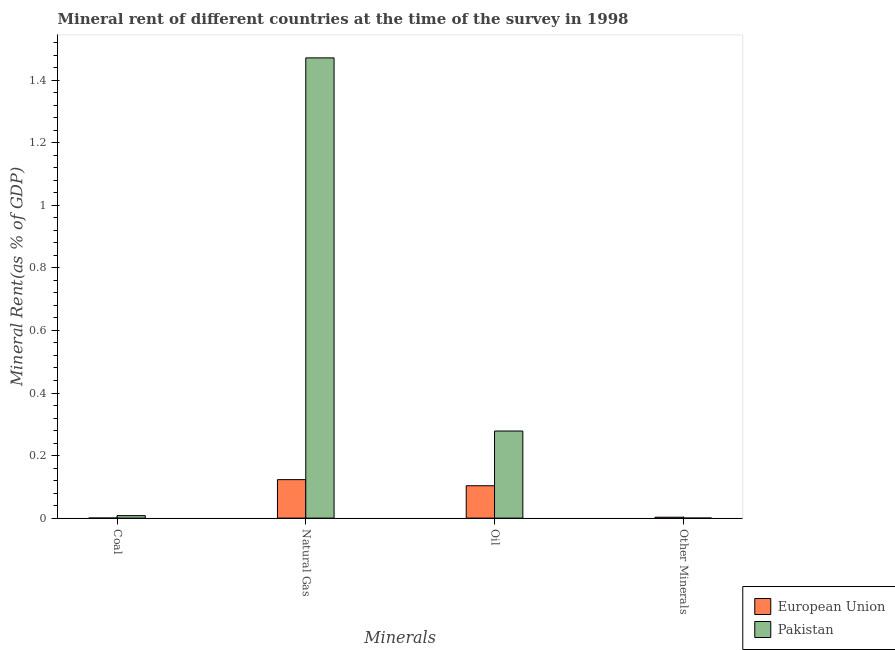How many groups of bars are there?
Give a very brief answer. 4. Are the number of bars per tick equal to the number of legend labels?
Your response must be concise. Yes. Are the number of bars on each tick of the X-axis equal?
Your answer should be very brief. Yes. How many bars are there on the 1st tick from the right?
Your response must be concise. 2. What is the label of the 2nd group of bars from the left?
Offer a terse response. Natural Gas. What is the natural gas rent in European Union?
Your response must be concise. 0.12. Across all countries, what is the maximum coal rent?
Provide a succinct answer. 0.01. Across all countries, what is the minimum  rent of other minerals?
Your response must be concise. 0. In which country was the coal rent maximum?
Your answer should be very brief. Pakistan. In which country was the  rent of other minerals minimum?
Provide a succinct answer. Pakistan. What is the total natural gas rent in the graph?
Make the answer very short. 1.59. What is the difference between the coal rent in European Union and that in Pakistan?
Provide a succinct answer. -0.01. What is the difference between the natural gas rent in European Union and the coal rent in Pakistan?
Ensure brevity in your answer.  0.11. What is the average  rent of other minerals per country?
Make the answer very short. 0. What is the difference between the  rent of other minerals and oil rent in Pakistan?
Your response must be concise. -0.28. In how many countries, is the coal rent greater than 0.28 %?
Provide a succinct answer. 0. What is the ratio of the  rent of other minerals in European Union to that in Pakistan?
Give a very brief answer. 25.04. Is the natural gas rent in European Union less than that in Pakistan?
Your answer should be very brief. Yes. Is the difference between the coal rent in European Union and Pakistan greater than the difference between the natural gas rent in European Union and Pakistan?
Give a very brief answer. Yes. What is the difference between the highest and the second highest  rent of other minerals?
Keep it short and to the point. 0. What is the difference between the highest and the lowest natural gas rent?
Ensure brevity in your answer.  1.35. Is the sum of the coal rent in Pakistan and European Union greater than the maximum  rent of other minerals across all countries?
Your answer should be very brief. Yes. Is it the case that in every country, the sum of the natural gas rent and  rent of other minerals is greater than the sum of oil rent and coal rent?
Provide a short and direct response. No. What does the 2nd bar from the right in Other Minerals represents?
Your answer should be compact. European Union. What is the difference between two consecutive major ticks on the Y-axis?
Your response must be concise. 0.2. Does the graph contain any zero values?
Keep it short and to the point. No. Where does the legend appear in the graph?
Keep it short and to the point. Bottom right. How are the legend labels stacked?
Your answer should be compact. Vertical. What is the title of the graph?
Provide a short and direct response. Mineral rent of different countries at the time of the survey in 1998. What is the label or title of the X-axis?
Your answer should be very brief. Minerals. What is the label or title of the Y-axis?
Ensure brevity in your answer.  Mineral Rent(as % of GDP). What is the Mineral Rent(as % of GDP) of European Union in Coal?
Your answer should be very brief. 0. What is the Mineral Rent(as % of GDP) in Pakistan in Coal?
Keep it short and to the point. 0.01. What is the Mineral Rent(as % of GDP) in European Union in Natural Gas?
Provide a short and direct response. 0.12. What is the Mineral Rent(as % of GDP) in Pakistan in Natural Gas?
Ensure brevity in your answer.  1.47. What is the Mineral Rent(as % of GDP) in European Union in Oil?
Offer a terse response. 0.1. What is the Mineral Rent(as % of GDP) of Pakistan in Oil?
Ensure brevity in your answer.  0.28. What is the Mineral Rent(as % of GDP) of European Union in Other Minerals?
Your answer should be compact. 0. What is the Mineral Rent(as % of GDP) of Pakistan in Other Minerals?
Ensure brevity in your answer.  0. Across all Minerals, what is the maximum Mineral Rent(as % of GDP) of European Union?
Provide a succinct answer. 0.12. Across all Minerals, what is the maximum Mineral Rent(as % of GDP) in Pakistan?
Keep it short and to the point. 1.47. Across all Minerals, what is the minimum Mineral Rent(as % of GDP) of European Union?
Provide a short and direct response. 0. Across all Minerals, what is the minimum Mineral Rent(as % of GDP) of Pakistan?
Your response must be concise. 0. What is the total Mineral Rent(as % of GDP) in European Union in the graph?
Provide a succinct answer. 0.23. What is the total Mineral Rent(as % of GDP) in Pakistan in the graph?
Your answer should be very brief. 1.76. What is the difference between the Mineral Rent(as % of GDP) in European Union in Coal and that in Natural Gas?
Offer a terse response. -0.12. What is the difference between the Mineral Rent(as % of GDP) in Pakistan in Coal and that in Natural Gas?
Provide a succinct answer. -1.46. What is the difference between the Mineral Rent(as % of GDP) of European Union in Coal and that in Oil?
Offer a very short reply. -0.1. What is the difference between the Mineral Rent(as % of GDP) of Pakistan in Coal and that in Oil?
Your answer should be very brief. -0.27. What is the difference between the Mineral Rent(as % of GDP) in European Union in Coal and that in Other Minerals?
Your answer should be compact. -0. What is the difference between the Mineral Rent(as % of GDP) in Pakistan in Coal and that in Other Minerals?
Offer a terse response. 0.01. What is the difference between the Mineral Rent(as % of GDP) in European Union in Natural Gas and that in Oil?
Offer a terse response. 0.02. What is the difference between the Mineral Rent(as % of GDP) in Pakistan in Natural Gas and that in Oil?
Your response must be concise. 1.19. What is the difference between the Mineral Rent(as % of GDP) of European Union in Natural Gas and that in Other Minerals?
Provide a succinct answer. 0.12. What is the difference between the Mineral Rent(as % of GDP) of Pakistan in Natural Gas and that in Other Minerals?
Offer a terse response. 1.47. What is the difference between the Mineral Rent(as % of GDP) of European Union in Oil and that in Other Minerals?
Ensure brevity in your answer.  0.1. What is the difference between the Mineral Rent(as % of GDP) in Pakistan in Oil and that in Other Minerals?
Your answer should be compact. 0.28. What is the difference between the Mineral Rent(as % of GDP) of European Union in Coal and the Mineral Rent(as % of GDP) of Pakistan in Natural Gas?
Offer a terse response. -1.47. What is the difference between the Mineral Rent(as % of GDP) of European Union in Coal and the Mineral Rent(as % of GDP) of Pakistan in Oil?
Keep it short and to the point. -0.28. What is the difference between the Mineral Rent(as % of GDP) in European Union in Coal and the Mineral Rent(as % of GDP) in Pakistan in Other Minerals?
Ensure brevity in your answer.  0. What is the difference between the Mineral Rent(as % of GDP) of European Union in Natural Gas and the Mineral Rent(as % of GDP) of Pakistan in Oil?
Give a very brief answer. -0.16. What is the difference between the Mineral Rent(as % of GDP) in European Union in Natural Gas and the Mineral Rent(as % of GDP) in Pakistan in Other Minerals?
Ensure brevity in your answer.  0.12. What is the difference between the Mineral Rent(as % of GDP) of European Union in Oil and the Mineral Rent(as % of GDP) of Pakistan in Other Minerals?
Provide a short and direct response. 0.1. What is the average Mineral Rent(as % of GDP) of European Union per Minerals?
Your answer should be compact. 0.06. What is the average Mineral Rent(as % of GDP) in Pakistan per Minerals?
Your response must be concise. 0.44. What is the difference between the Mineral Rent(as % of GDP) in European Union and Mineral Rent(as % of GDP) in Pakistan in Coal?
Your answer should be very brief. -0.01. What is the difference between the Mineral Rent(as % of GDP) in European Union and Mineral Rent(as % of GDP) in Pakistan in Natural Gas?
Keep it short and to the point. -1.35. What is the difference between the Mineral Rent(as % of GDP) of European Union and Mineral Rent(as % of GDP) of Pakistan in Oil?
Make the answer very short. -0.17. What is the difference between the Mineral Rent(as % of GDP) in European Union and Mineral Rent(as % of GDP) in Pakistan in Other Minerals?
Offer a very short reply. 0. What is the ratio of the Mineral Rent(as % of GDP) of European Union in Coal to that in Natural Gas?
Offer a very short reply. 0. What is the ratio of the Mineral Rent(as % of GDP) of Pakistan in Coal to that in Natural Gas?
Make the answer very short. 0.01. What is the ratio of the Mineral Rent(as % of GDP) in European Union in Coal to that in Oil?
Give a very brief answer. 0. What is the ratio of the Mineral Rent(as % of GDP) of Pakistan in Coal to that in Oil?
Make the answer very short. 0.03. What is the ratio of the Mineral Rent(as % of GDP) of European Union in Coal to that in Other Minerals?
Provide a succinct answer. 0.05. What is the ratio of the Mineral Rent(as % of GDP) of Pakistan in Coal to that in Other Minerals?
Your answer should be very brief. 70.03. What is the ratio of the Mineral Rent(as % of GDP) in European Union in Natural Gas to that in Oil?
Give a very brief answer. 1.19. What is the ratio of the Mineral Rent(as % of GDP) in Pakistan in Natural Gas to that in Oil?
Ensure brevity in your answer.  5.28. What is the ratio of the Mineral Rent(as % of GDP) in European Union in Natural Gas to that in Other Minerals?
Your answer should be very brief. 42.74. What is the ratio of the Mineral Rent(as % of GDP) in Pakistan in Natural Gas to that in Other Minerals?
Your answer should be compact. 1.28e+04. What is the ratio of the Mineral Rent(as % of GDP) in European Union in Oil to that in Other Minerals?
Offer a terse response. 35.96. What is the ratio of the Mineral Rent(as % of GDP) of Pakistan in Oil to that in Other Minerals?
Offer a terse response. 2422.3. What is the difference between the highest and the second highest Mineral Rent(as % of GDP) in European Union?
Offer a very short reply. 0.02. What is the difference between the highest and the second highest Mineral Rent(as % of GDP) in Pakistan?
Ensure brevity in your answer.  1.19. What is the difference between the highest and the lowest Mineral Rent(as % of GDP) in European Union?
Your answer should be very brief. 0.12. What is the difference between the highest and the lowest Mineral Rent(as % of GDP) of Pakistan?
Your answer should be compact. 1.47. 